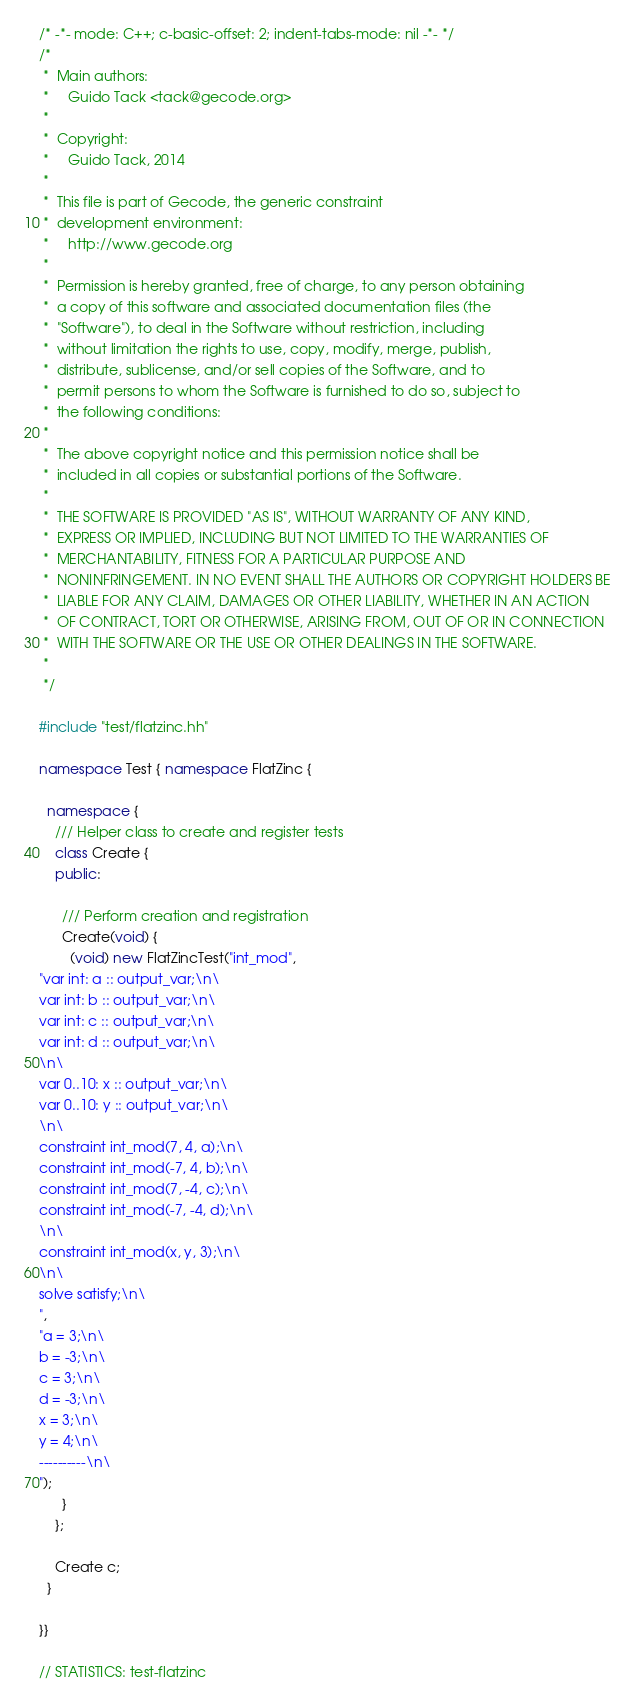<code> <loc_0><loc_0><loc_500><loc_500><_C++_>/* -*- mode: C++; c-basic-offset: 2; indent-tabs-mode: nil -*- */
/*
 *  Main authors:
 *     Guido Tack <tack@gecode.org>
 *
 *  Copyright:
 *     Guido Tack, 2014
 *
 *  This file is part of Gecode, the generic constraint
 *  development environment:
 *     http://www.gecode.org
 *
 *  Permission is hereby granted, free of charge, to any person obtaining
 *  a copy of this software and associated documentation files (the
 *  "Software"), to deal in the Software without restriction, including
 *  without limitation the rights to use, copy, modify, merge, publish,
 *  distribute, sublicense, and/or sell copies of the Software, and to
 *  permit persons to whom the Software is furnished to do so, subject to
 *  the following conditions:
 *
 *  The above copyright notice and this permission notice shall be
 *  included in all copies or substantial portions of the Software.
 *
 *  THE SOFTWARE IS PROVIDED "AS IS", WITHOUT WARRANTY OF ANY KIND,
 *  EXPRESS OR IMPLIED, INCLUDING BUT NOT LIMITED TO THE WARRANTIES OF
 *  MERCHANTABILITY, FITNESS FOR A PARTICULAR PURPOSE AND
 *  NONINFRINGEMENT. IN NO EVENT SHALL THE AUTHORS OR COPYRIGHT HOLDERS BE
 *  LIABLE FOR ANY CLAIM, DAMAGES OR OTHER LIABILITY, WHETHER IN AN ACTION
 *  OF CONTRACT, TORT OR OTHERWISE, ARISING FROM, OUT OF OR IN CONNECTION
 *  WITH THE SOFTWARE OR THE USE OR OTHER DEALINGS IN THE SOFTWARE.
 *
 */

#include "test/flatzinc.hh"

namespace Test { namespace FlatZinc {

  namespace {
    /// Helper class to create and register tests
    class Create {
    public:

      /// Perform creation and registration
      Create(void) {
        (void) new FlatZincTest("int_mod",
"var int: a :: output_var;\n\
var int: b :: output_var;\n\
var int: c :: output_var;\n\
var int: d :: output_var;\n\
\n\
var 0..10: x :: output_var;\n\
var 0..10: y :: output_var;\n\
\n\
constraint int_mod(7, 4, a);\n\
constraint int_mod(-7, 4, b);\n\
constraint int_mod(7, -4, c);\n\
constraint int_mod(-7, -4, d);\n\
\n\
constraint int_mod(x, y, 3);\n\
\n\
solve satisfy;\n\
",
"a = 3;\n\
b = -3;\n\
c = 3;\n\
d = -3;\n\
x = 3;\n\
y = 4;\n\
----------\n\
");
      }
    };

    Create c;
  }

}}

// STATISTICS: test-flatzinc
</code> 